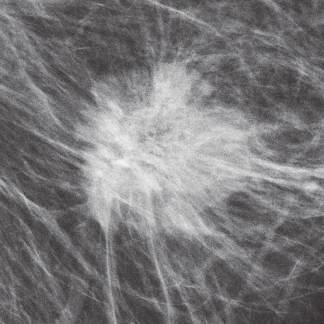what appear as dense masses with spicular margins resulting from invasion of adjacent radiolucent breast tissue in mammograms b?
Answer the question using a single word or phrase. Invasive breast carcinomas 